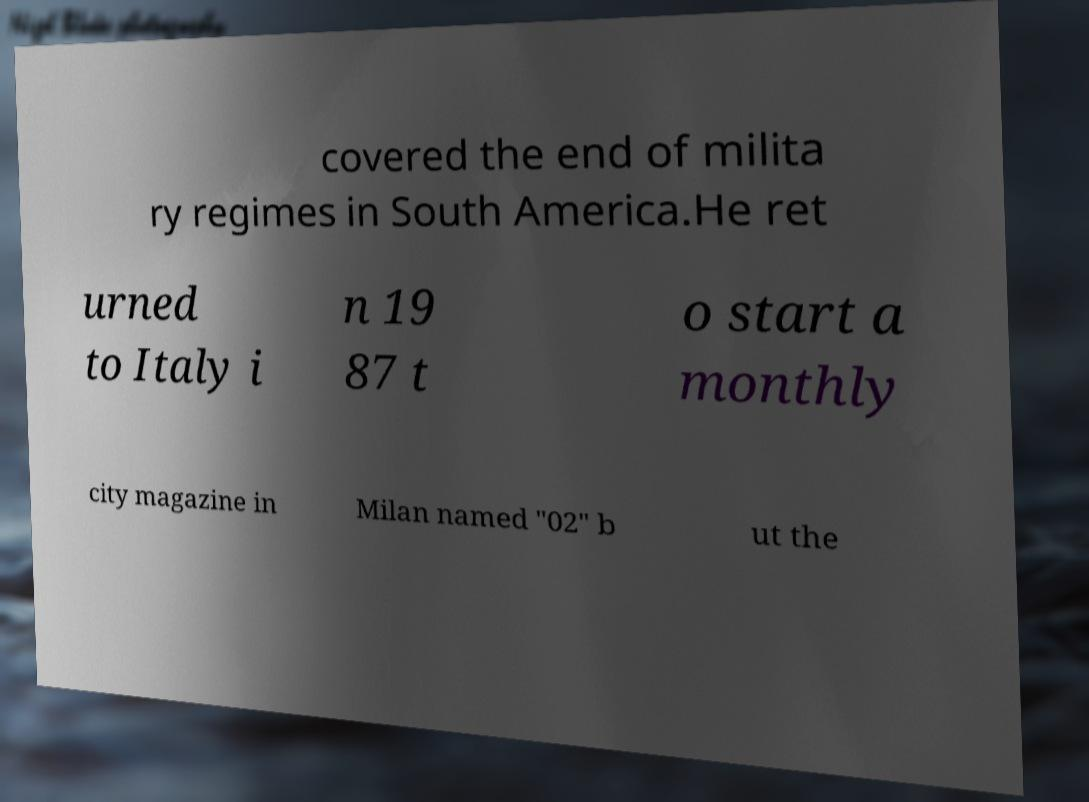Could you extract and type out the text from this image? covered the end of milita ry regimes in South America.He ret urned to Italy i n 19 87 t o start a monthly city magazine in Milan named "02" b ut the 